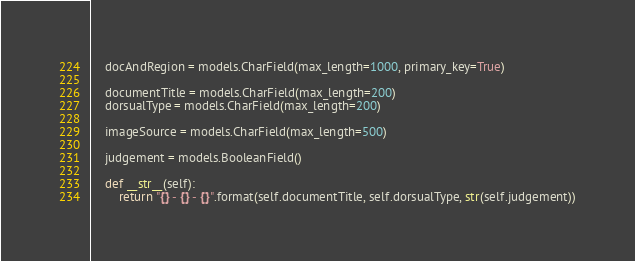Convert code to text. <code><loc_0><loc_0><loc_500><loc_500><_Python_>    docAndRegion = models.CharField(max_length=1000, primary_key=True)

    documentTitle = models.CharField(max_length=200)
    dorsualType = models.CharField(max_length=200)

    imageSource = models.CharField(max_length=500)

    judgement = models.BooleanField()

    def __str__(self):
        return "{} - {} - {}".format(self.documentTitle, self.dorsualType, str(self.judgement))
</code> 